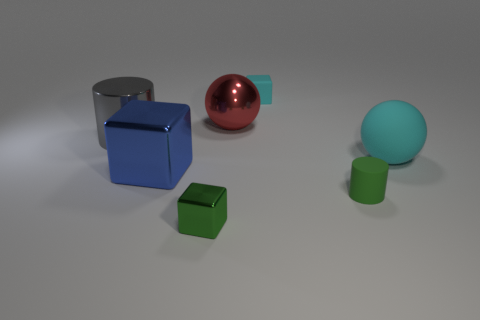There is a tiny matte object in front of the large gray cylinder; does it have the same shape as the large gray thing?
Give a very brief answer. Yes. There is a cylinder to the right of the matte block; what is its color?
Offer a very short reply. Green. How many other objects are the same size as the green cube?
Offer a very short reply. 2. Are there the same number of gray objects that are on the right side of the small cyan matte block and tiny purple matte cylinders?
Provide a succinct answer. Yes. What number of small green things are made of the same material as the tiny green cylinder?
Offer a terse response. 0. What is the color of the cylinder that is the same material as the big blue object?
Provide a short and direct response. Gray. Is the green metal thing the same shape as the blue metallic thing?
Give a very brief answer. Yes. Are there any green metallic things that are on the left side of the big metallic cube that is on the left side of the small cube that is in front of the small rubber block?
Make the answer very short. No. How many cubes are the same color as the rubber sphere?
Offer a terse response. 1. There is a rubber thing that is the same size as the rubber cube; what shape is it?
Offer a very short reply. Cylinder. 